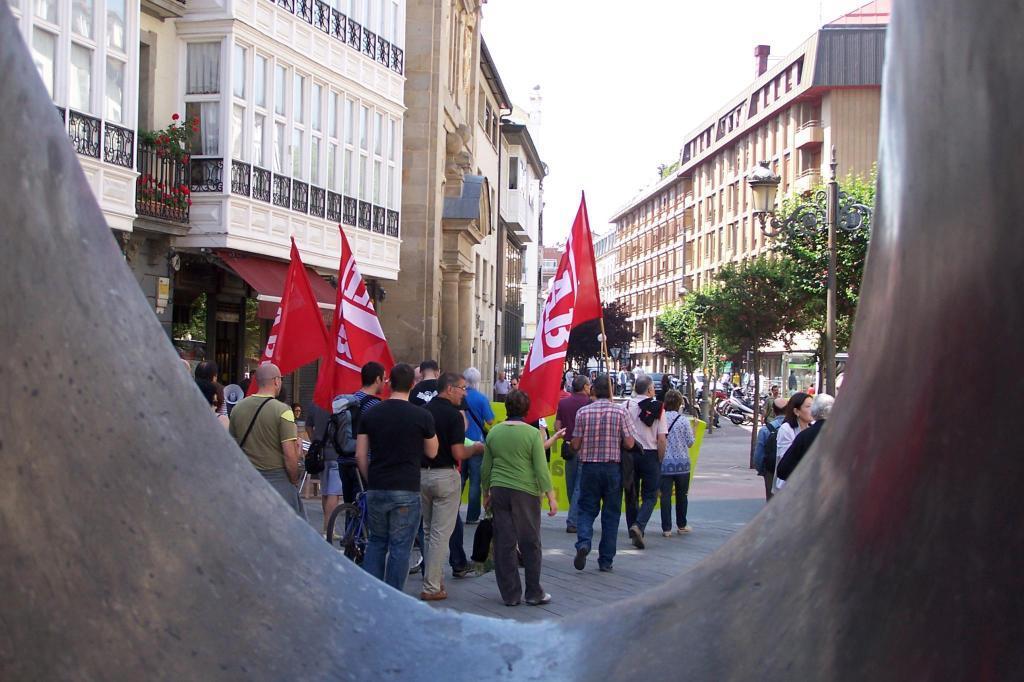How would you summarize this image in a sentence or two? In this image we can see people standing on the road and some of them are holding flags in the hands. In the background there are buildings, street poles, street lights, grills, plants, trees and sky. 